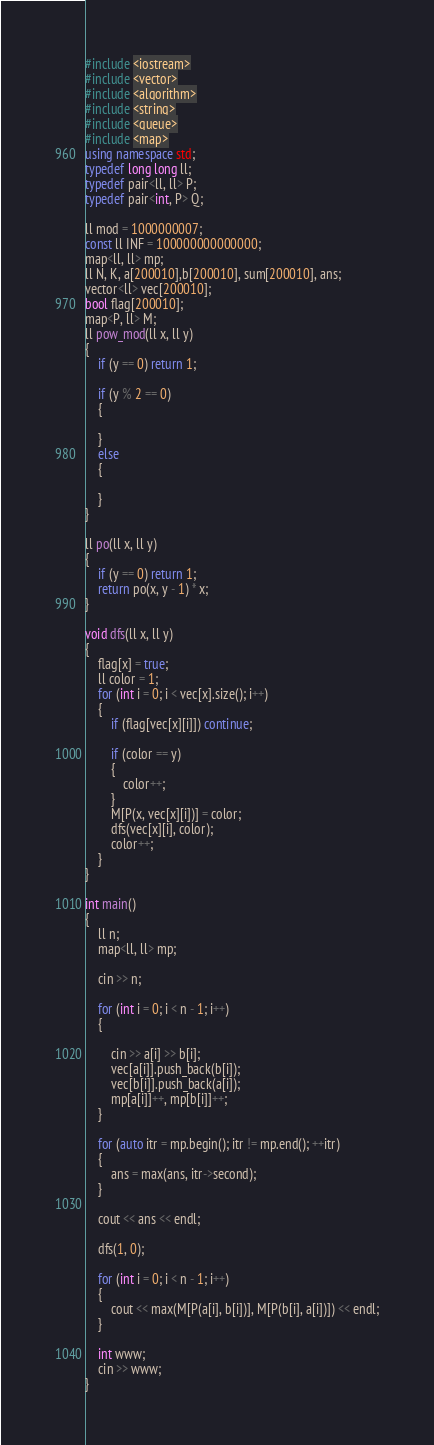Convert code to text. <code><loc_0><loc_0><loc_500><loc_500><_C++_>#include <iostream>
#include <vector>
#include <algorithm>
#include <string>
#include <queue>
#include <map>
using namespace std;
typedef long long ll;
typedef pair<ll, ll> P;
typedef pair<int, P> Q;

ll mod = 1000000007;
const ll INF = 100000000000000;
map<ll, ll> mp;
ll N, K, a[200010],b[200010], sum[200010], ans;
vector<ll> vec[200010];
bool flag[200010];
map<P, ll> M;
ll pow_mod(ll x, ll y)
{
	if (y == 0) return 1;

	if (y % 2 == 0)
	{

	}
	else
	{

	}
}

ll po(ll x, ll y)
{
	if (y == 0) return 1;
	return po(x, y - 1) * x;
}

void dfs(ll x, ll y)
{
	flag[x] = true;
	ll color = 1;
	for (int i = 0; i < vec[x].size(); i++)
	{
		if (flag[vec[x][i]]) continue;

		if (color == y)
		{
			color++;
		}
		M[P(x, vec[x][i])] = color;
		dfs(vec[x][i], color);
		color++;
	}
}

int main()
{
	ll n;
	map<ll, ll> mp;
	
	cin >> n;

	for (int i = 0; i < n - 1; i++)
	{
		
		cin >> a[i] >> b[i];
		vec[a[i]].push_back(b[i]);
		vec[b[i]].push_back(a[i]);
		mp[a[i]]++, mp[b[i]]++;
	}

	for (auto itr = mp.begin(); itr != mp.end(); ++itr)
	{
		ans = max(ans, itr->second);
	}

	cout << ans << endl;
	
	dfs(1, 0);

	for (int i = 0; i < n - 1; i++)
	{
		cout << max(M[P(a[i], b[i])], M[P(b[i], a[i])]) << endl;
	}

	int www;
	cin >> www;
}</code> 